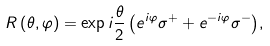<formula> <loc_0><loc_0><loc_500><loc_500>R \left ( \theta , \varphi \right ) = \exp { i \frac { \theta } { 2 } \left ( e ^ { i \varphi } \sigma ^ { + } + e ^ { - i \varphi } \sigma ^ { - } \right ) } ,</formula> 